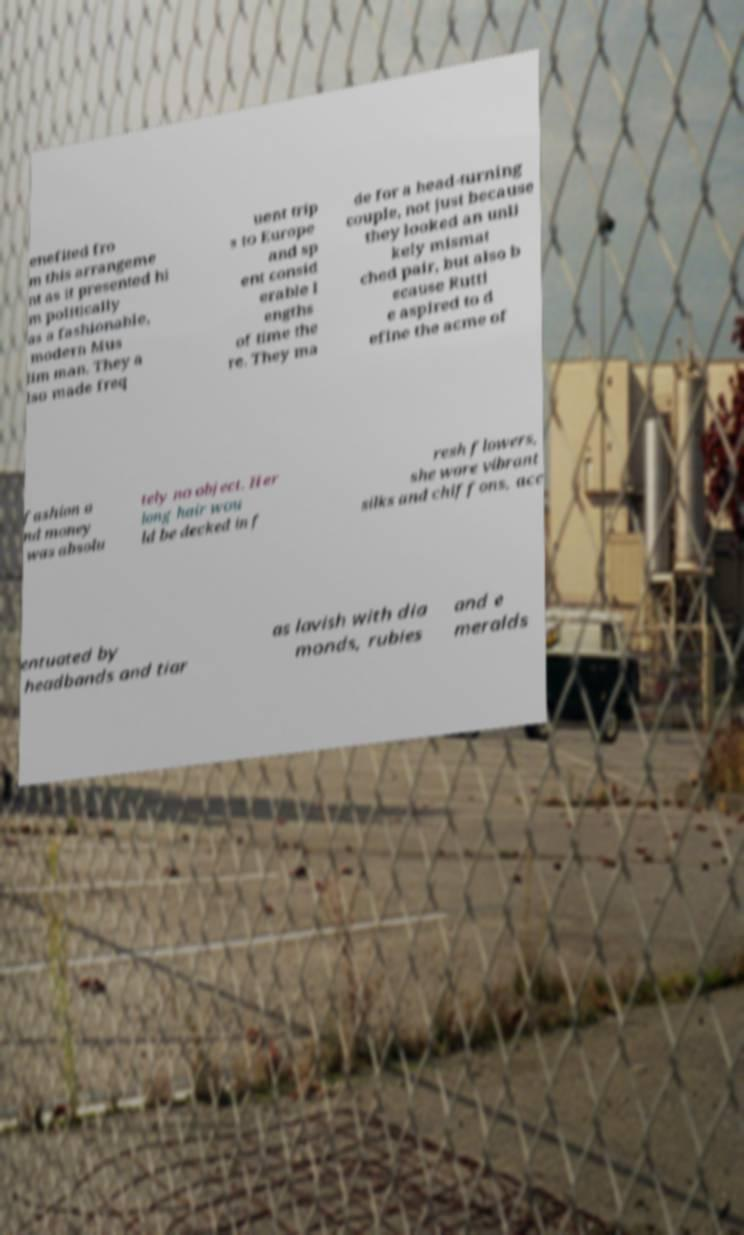Could you assist in decoding the text presented in this image and type it out clearly? enefited fro m this arrangeme nt as it presented hi m politically as a fashionable, modern Mus lim man. They a lso made freq uent trip s to Europe and sp ent consid erable l engths of time the re. They ma de for a head-turning couple, not just because they looked an unli kely mismat ched pair, but also b ecause Rutti e aspired to d efine the acme of fashion a nd money was absolu tely no object. Her long hair wou ld be decked in f resh flowers, she wore vibrant silks and chiffons, acc entuated by headbands and tiar as lavish with dia monds, rubies and e meralds 